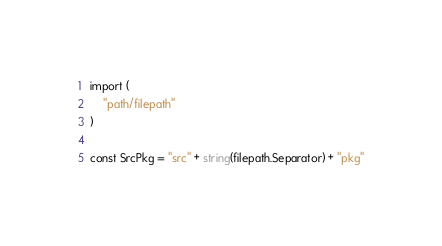<code> <loc_0><loc_0><loc_500><loc_500><_Go_>import (
	"path/filepath"
)

const SrcPkg = "src" + string(filepath.Separator) + "pkg"
</code> 